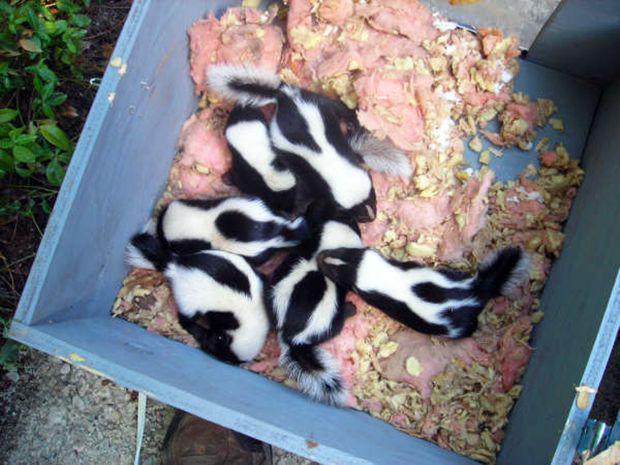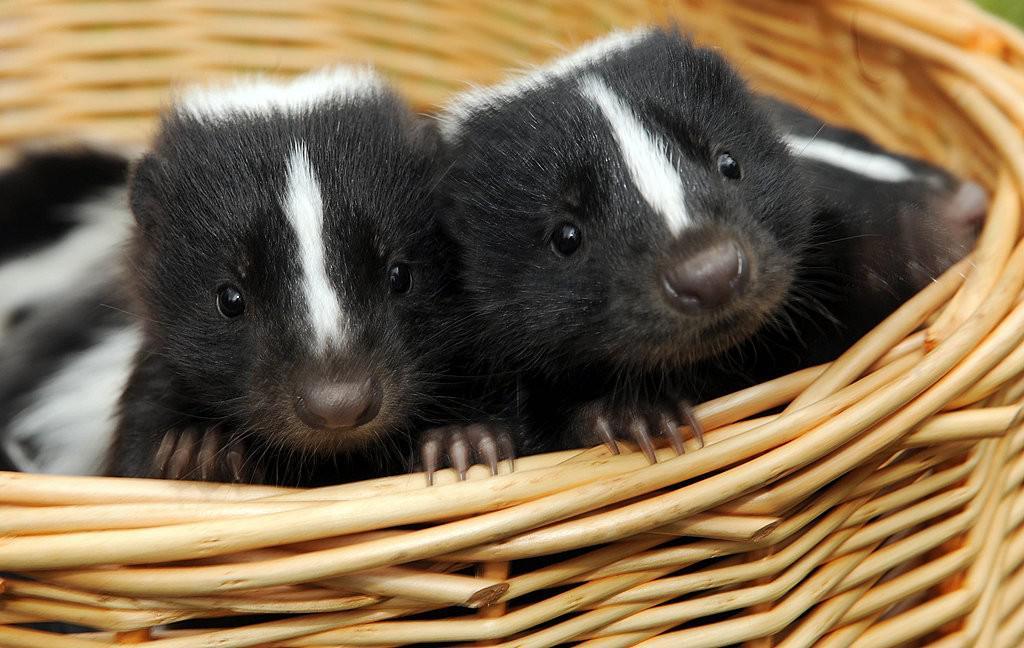The first image is the image on the left, the second image is the image on the right. Analyze the images presented: Is the assertion "Right and left images feature young skunks in containers, but only the container on the left has white bedding in it." valid? Answer yes or no. No. The first image is the image on the left, the second image is the image on the right. Analyze the images presented: Is the assertion "All the skunks are in containers." valid? Answer yes or no. Yes. 